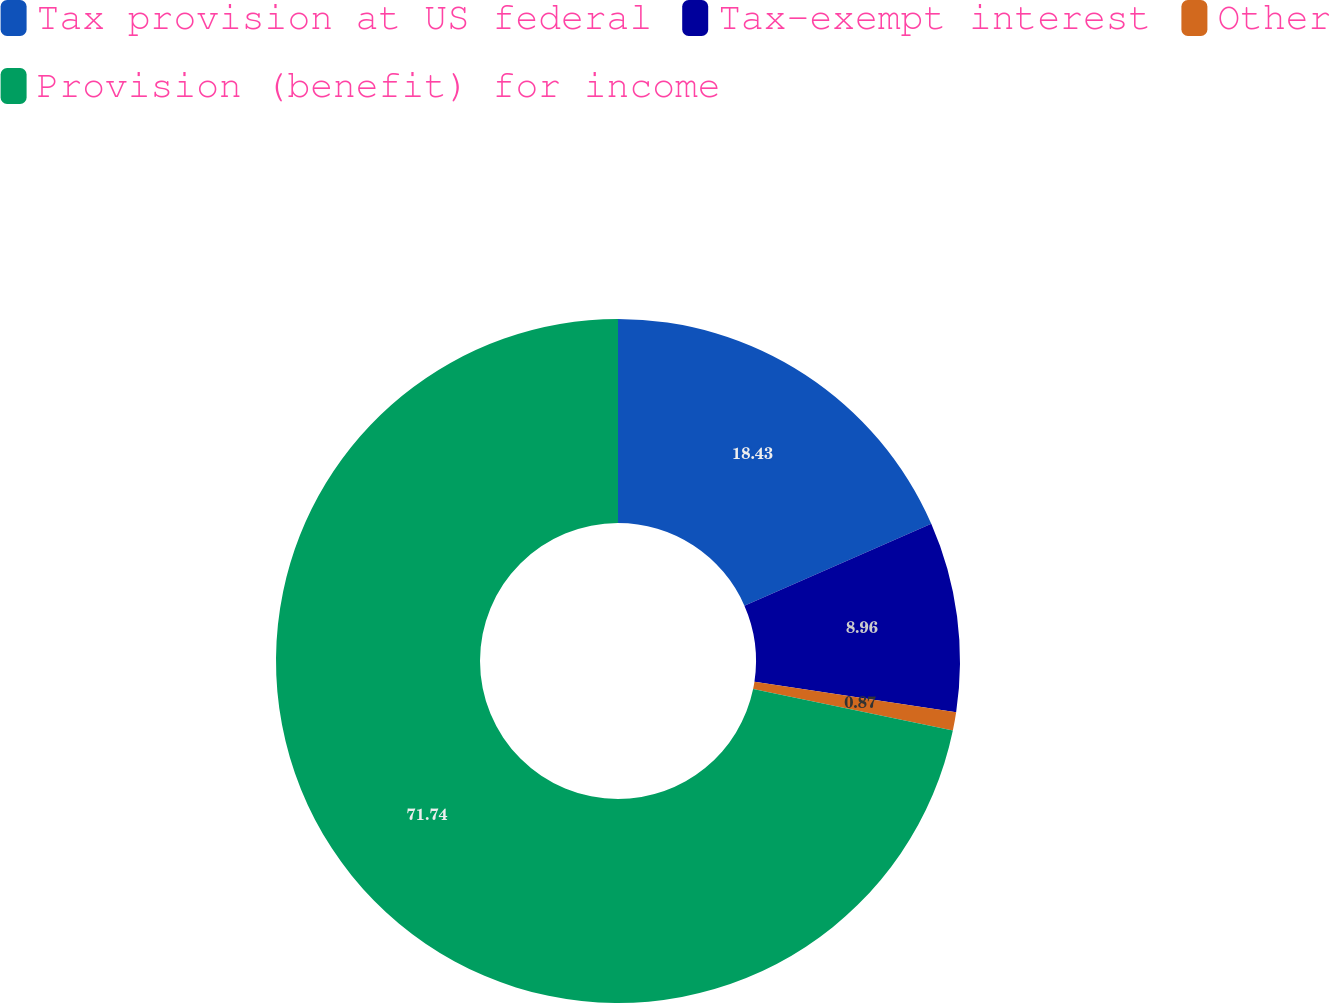Convert chart to OTSL. <chart><loc_0><loc_0><loc_500><loc_500><pie_chart><fcel>Tax provision at US federal<fcel>Tax-exempt interest<fcel>Other<fcel>Provision (benefit) for income<nl><fcel>18.43%<fcel>8.96%<fcel>0.87%<fcel>71.74%<nl></chart> 